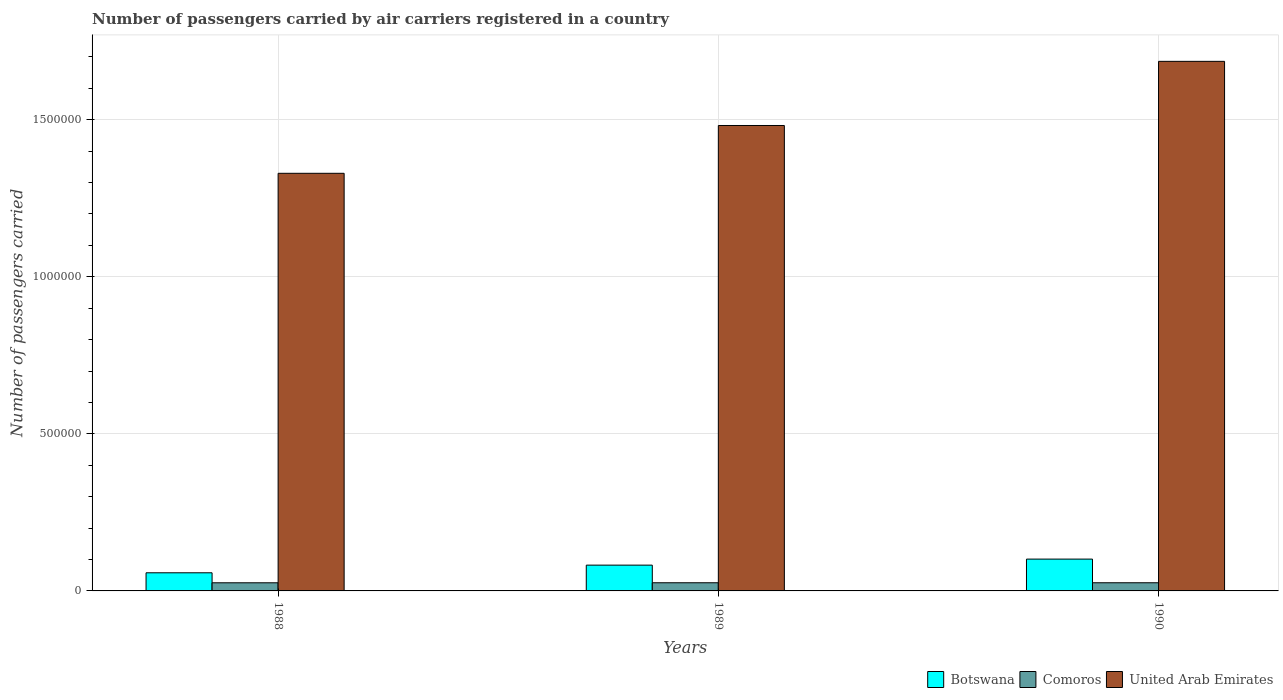How many different coloured bars are there?
Your answer should be very brief. 3. Are the number of bars on each tick of the X-axis equal?
Keep it short and to the point. Yes. How many bars are there on the 2nd tick from the left?
Give a very brief answer. 3. In how many cases, is the number of bars for a given year not equal to the number of legend labels?
Your response must be concise. 0. What is the number of passengers carried by air carriers in Comoros in 1990?
Your answer should be very brief. 2.60e+04. Across all years, what is the maximum number of passengers carried by air carriers in Comoros?
Your answer should be very brief. 2.60e+04. Across all years, what is the minimum number of passengers carried by air carriers in Comoros?
Make the answer very short. 2.59e+04. In which year was the number of passengers carried by air carriers in United Arab Emirates minimum?
Provide a succinct answer. 1988. What is the total number of passengers carried by air carriers in United Arab Emirates in the graph?
Provide a short and direct response. 4.50e+06. What is the difference between the number of passengers carried by air carriers in Comoros in 1989 and that in 1990?
Your response must be concise. 0. What is the difference between the number of passengers carried by air carriers in Comoros in 1989 and the number of passengers carried by air carriers in Botswana in 1990?
Offer a terse response. -7.53e+04. What is the average number of passengers carried by air carriers in United Arab Emirates per year?
Offer a very short reply. 1.50e+06. In the year 1990, what is the difference between the number of passengers carried by air carriers in United Arab Emirates and number of passengers carried by air carriers in Comoros?
Make the answer very short. 1.66e+06. What is the ratio of the number of passengers carried by air carriers in Botswana in 1988 to that in 1990?
Provide a short and direct response. 0.57. Is the number of passengers carried by air carriers in Botswana in 1989 less than that in 1990?
Provide a succinct answer. Yes. What is the difference between the highest and the second highest number of passengers carried by air carriers in Comoros?
Make the answer very short. 0. What is the difference between the highest and the lowest number of passengers carried by air carriers in Botswana?
Make the answer very short. 4.36e+04. Is the sum of the number of passengers carried by air carriers in Comoros in 1988 and 1990 greater than the maximum number of passengers carried by air carriers in Botswana across all years?
Make the answer very short. No. What does the 1st bar from the left in 1989 represents?
Give a very brief answer. Botswana. What does the 2nd bar from the right in 1988 represents?
Make the answer very short. Comoros. Is it the case that in every year, the sum of the number of passengers carried by air carriers in Comoros and number of passengers carried by air carriers in United Arab Emirates is greater than the number of passengers carried by air carriers in Botswana?
Your answer should be compact. Yes. Are all the bars in the graph horizontal?
Ensure brevity in your answer.  No. How many years are there in the graph?
Ensure brevity in your answer.  3. What is the difference between two consecutive major ticks on the Y-axis?
Provide a succinct answer. 5.00e+05. Does the graph contain grids?
Your answer should be very brief. Yes. How many legend labels are there?
Keep it short and to the point. 3. How are the legend labels stacked?
Offer a very short reply. Horizontal. What is the title of the graph?
Your response must be concise. Number of passengers carried by air carriers registered in a country. Does "Iran" appear as one of the legend labels in the graph?
Offer a very short reply. No. What is the label or title of the X-axis?
Provide a succinct answer. Years. What is the label or title of the Y-axis?
Keep it short and to the point. Number of passengers carried. What is the Number of passengers carried of Botswana in 1988?
Give a very brief answer. 5.77e+04. What is the Number of passengers carried of Comoros in 1988?
Give a very brief answer. 2.59e+04. What is the Number of passengers carried of United Arab Emirates in 1988?
Make the answer very short. 1.33e+06. What is the Number of passengers carried in Botswana in 1989?
Your answer should be compact. 8.21e+04. What is the Number of passengers carried of Comoros in 1989?
Ensure brevity in your answer.  2.60e+04. What is the Number of passengers carried of United Arab Emirates in 1989?
Provide a succinct answer. 1.48e+06. What is the Number of passengers carried in Botswana in 1990?
Provide a short and direct response. 1.01e+05. What is the Number of passengers carried in Comoros in 1990?
Give a very brief answer. 2.60e+04. What is the Number of passengers carried of United Arab Emirates in 1990?
Offer a terse response. 1.69e+06. Across all years, what is the maximum Number of passengers carried of Botswana?
Ensure brevity in your answer.  1.01e+05. Across all years, what is the maximum Number of passengers carried of Comoros?
Provide a succinct answer. 2.60e+04. Across all years, what is the maximum Number of passengers carried of United Arab Emirates?
Give a very brief answer. 1.69e+06. Across all years, what is the minimum Number of passengers carried in Botswana?
Your answer should be compact. 5.77e+04. Across all years, what is the minimum Number of passengers carried in Comoros?
Your answer should be compact. 2.59e+04. Across all years, what is the minimum Number of passengers carried of United Arab Emirates?
Provide a short and direct response. 1.33e+06. What is the total Number of passengers carried of Botswana in the graph?
Your response must be concise. 2.41e+05. What is the total Number of passengers carried of Comoros in the graph?
Ensure brevity in your answer.  7.79e+04. What is the total Number of passengers carried in United Arab Emirates in the graph?
Offer a very short reply. 4.50e+06. What is the difference between the Number of passengers carried of Botswana in 1988 and that in 1989?
Ensure brevity in your answer.  -2.44e+04. What is the difference between the Number of passengers carried of Comoros in 1988 and that in 1989?
Your answer should be compact. -100. What is the difference between the Number of passengers carried in United Arab Emirates in 1988 and that in 1989?
Offer a very short reply. -1.52e+05. What is the difference between the Number of passengers carried of Botswana in 1988 and that in 1990?
Ensure brevity in your answer.  -4.36e+04. What is the difference between the Number of passengers carried of Comoros in 1988 and that in 1990?
Keep it short and to the point. -100. What is the difference between the Number of passengers carried in United Arab Emirates in 1988 and that in 1990?
Ensure brevity in your answer.  -3.56e+05. What is the difference between the Number of passengers carried in Botswana in 1989 and that in 1990?
Offer a very short reply. -1.92e+04. What is the difference between the Number of passengers carried in Comoros in 1989 and that in 1990?
Your answer should be very brief. 0. What is the difference between the Number of passengers carried in United Arab Emirates in 1989 and that in 1990?
Ensure brevity in your answer.  -2.04e+05. What is the difference between the Number of passengers carried of Botswana in 1988 and the Number of passengers carried of Comoros in 1989?
Make the answer very short. 3.17e+04. What is the difference between the Number of passengers carried of Botswana in 1988 and the Number of passengers carried of United Arab Emirates in 1989?
Your answer should be compact. -1.42e+06. What is the difference between the Number of passengers carried of Comoros in 1988 and the Number of passengers carried of United Arab Emirates in 1989?
Your response must be concise. -1.46e+06. What is the difference between the Number of passengers carried in Botswana in 1988 and the Number of passengers carried in Comoros in 1990?
Make the answer very short. 3.17e+04. What is the difference between the Number of passengers carried of Botswana in 1988 and the Number of passengers carried of United Arab Emirates in 1990?
Give a very brief answer. -1.63e+06. What is the difference between the Number of passengers carried of Comoros in 1988 and the Number of passengers carried of United Arab Emirates in 1990?
Offer a terse response. -1.66e+06. What is the difference between the Number of passengers carried of Botswana in 1989 and the Number of passengers carried of Comoros in 1990?
Provide a succinct answer. 5.61e+04. What is the difference between the Number of passengers carried in Botswana in 1989 and the Number of passengers carried in United Arab Emirates in 1990?
Your answer should be compact. -1.60e+06. What is the difference between the Number of passengers carried of Comoros in 1989 and the Number of passengers carried of United Arab Emirates in 1990?
Keep it short and to the point. -1.66e+06. What is the average Number of passengers carried in Botswana per year?
Your answer should be very brief. 8.04e+04. What is the average Number of passengers carried in Comoros per year?
Your answer should be very brief. 2.60e+04. What is the average Number of passengers carried in United Arab Emirates per year?
Provide a succinct answer. 1.50e+06. In the year 1988, what is the difference between the Number of passengers carried in Botswana and Number of passengers carried in Comoros?
Ensure brevity in your answer.  3.18e+04. In the year 1988, what is the difference between the Number of passengers carried in Botswana and Number of passengers carried in United Arab Emirates?
Your answer should be very brief. -1.27e+06. In the year 1988, what is the difference between the Number of passengers carried of Comoros and Number of passengers carried of United Arab Emirates?
Provide a succinct answer. -1.30e+06. In the year 1989, what is the difference between the Number of passengers carried of Botswana and Number of passengers carried of Comoros?
Offer a very short reply. 5.61e+04. In the year 1989, what is the difference between the Number of passengers carried in Botswana and Number of passengers carried in United Arab Emirates?
Your response must be concise. -1.40e+06. In the year 1989, what is the difference between the Number of passengers carried in Comoros and Number of passengers carried in United Arab Emirates?
Give a very brief answer. -1.46e+06. In the year 1990, what is the difference between the Number of passengers carried in Botswana and Number of passengers carried in Comoros?
Your response must be concise. 7.53e+04. In the year 1990, what is the difference between the Number of passengers carried in Botswana and Number of passengers carried in United Arab Emirates?
Your response must be concise. -1.58e+06. In the year 1990, what is the difference between the Number of passengers carried in Comoros and Number of passengers carried in United Arab Emirates?
Give a very brief answer. -1.66e+06. What is the ratio of the Number of passengers carried of Botswana in 1988 to that in 1989?
Provide a succinct answer. 0.7. What is the ratio of the Number of passengers carried of United Arab Emirates in 1988 to that in 1989?
Offer a very short reply. 0.9. What is the ratio of the Number of passengers carried in Botswana in 1988 to that in 1990?
Keep it short and to the point. 0.57. What is the ratio of the Number of passengers carried of United Arab Emirates in 1988 to that in 1990?
Provide a short and direct response. 0.79. What is the ratio of the Number of passengers carried in Botswana in 1989 to that in 1990?
Provide a short and direct response. 0.81. What is the ratio of the Number of passengers carried of Comoros in 1989 to that in 1990?
Offer a terse response. 1. What is the ratio of the Number of passengers carried of United Arab Emirates in 1989 to that in 1990?
Your response must be concise. 0.88. What is the difference between the highest and the second highest Number of passengers carried in Botswana?
Provide a succinct answer. 1.92e+04. What is the difference between the highest and the second highest Number of passengers carried of United Arab Emirates?
Your answer should be very brief. 2.04e+05. What is the difference between the highest and the lowest Number of passengers carried of Botswana?
Make the answer very short. 4.36e+04. What is the difference between the highest and the lowest Number of passengers carried in Comoros?
Your answer should be compact. 100. What is the difference between the highest and the lowest Number of passengers carried of United Arab Emirates?
Provide a short and direct response. 3.56e+05. 